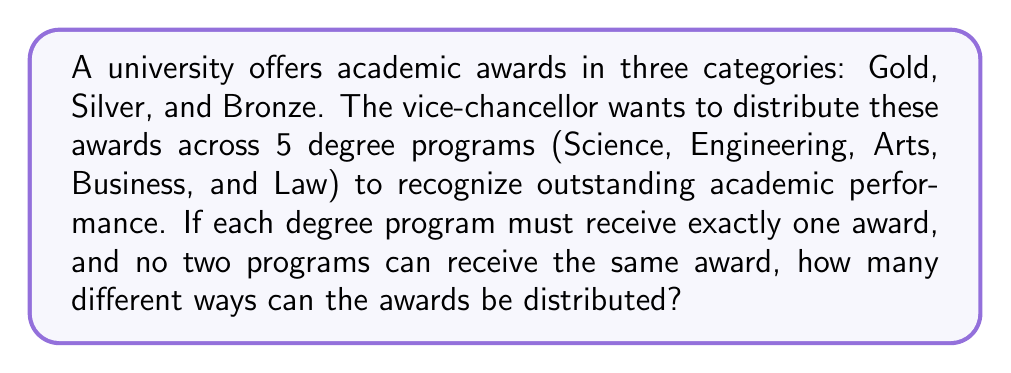Provide a solution to this math problem. Let's approach this step-by-step:

1) This is a permutation problem. We need to arrange 3 distinct awards among 5 distinct degree programs.

2) We can think of this as filling 3 positions (Gold, Silver, Bronze) with 3 out of the 5 degree programs.

3) For the first award (Gold):
   We have 5 choices of degree programs.

4) For the second award (Silver):
   We have 4 remaining choices of degree programs.

5) For the third award (Bronze):
   We have 3 remaining choices of degree programs.

6) According to the multiplication principle, the total number of ways to distribute the awards is:

   $$ 5 \times 4 \times 3 = 60 $$

7) This is equivalent to the permutation formula:

   $$ P(5,3) = \frac{5!}{(5-3)!} = \frac{5!}{2!} = 60 $$

Therefore, there are 60 different ways to distribute the awards across the degree programs.
Answer: 60 